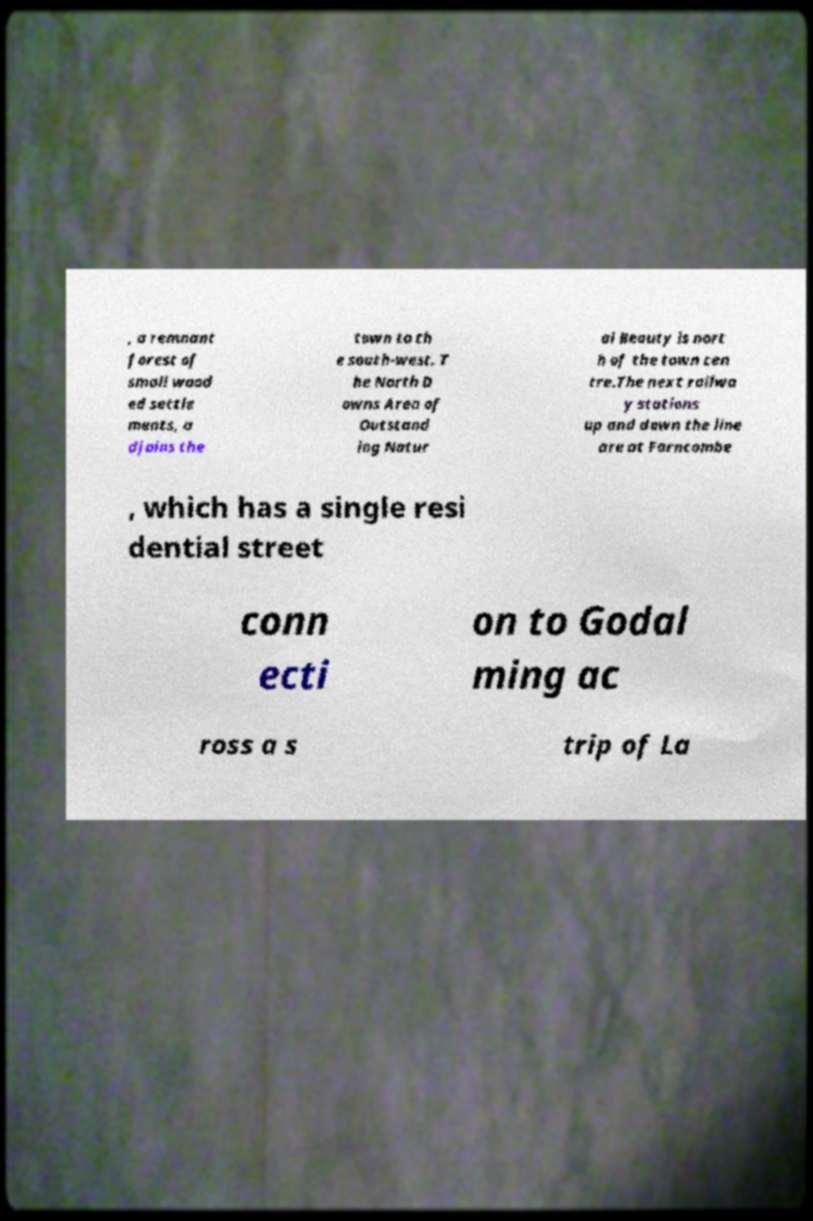Can you accurately transcribe the text from the provided image for me? , a remnant forest of small wood ed settle ments, a djoins the town to th e south-west. T he North D owns Area of Outstand ing Natur al Beauty is nort h of the town cen tre.The next railwa y stations up and down the line are at Farncombe , which has a single resi dential street conn ecti on to Godal ming ac ross a s trip of La 